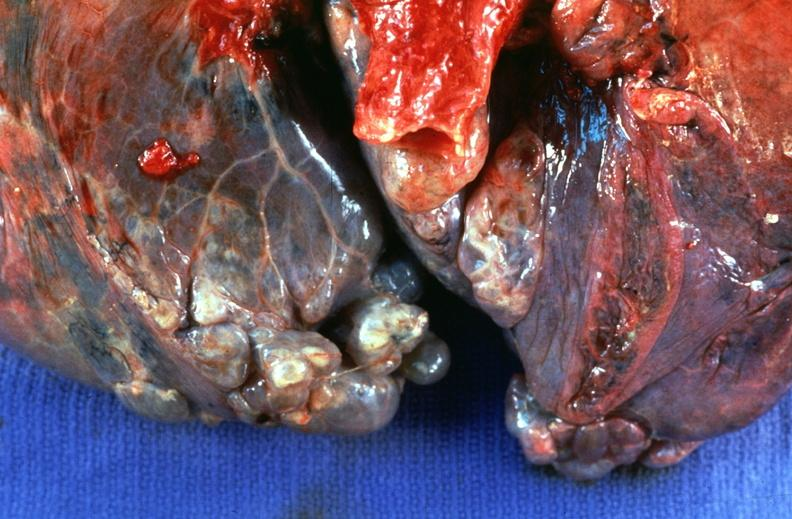what does this image show?
Answer the question using a single word or phrase. Lung 